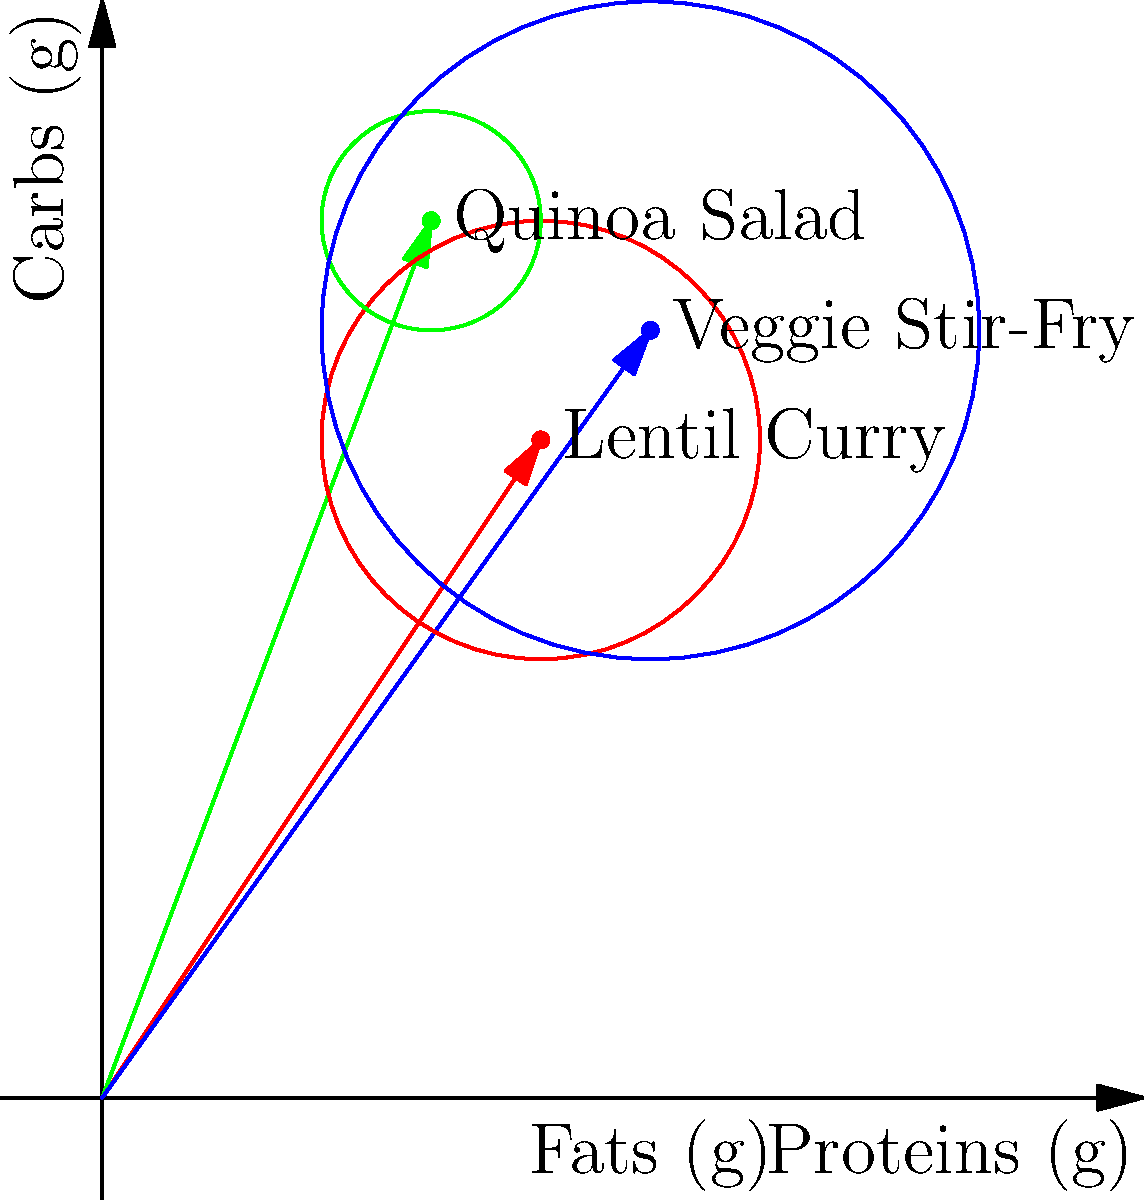Given the nutritional vectors for three vegetarian dishes (Lentil Curry, Quinoa Salad, and Veggie Stir-Fry) represented in the graph, where the x-axis shows proteins, y-axis shows carbs, and the circle size represents fats, calculate the total nutritional vector for a balanced meal consisting of equal portions of all three dishes. Express your answer as a vector in the form $(p, c, f)$, where $p$ is total proteins, $c$ is total carbs, and $f$ is total fats. To calculate the total nutritional vector for a balanced meal with equal portions of all three dishes, we need to follow these steps:

1. Identify the nutritional values for each dish:
   Lentil Curry: (20g protein, 30g carbs, 10g fat)
   Quinoa Salad: (15g protein, 40g carbs, 5g fat)
   Veggie Stir-Fry: (25g protein, 35g carbs, 15g fat)

2. Since we're using equal portions of each dish, we need to sum up the values for each nutrient:

   Proteins: $20 + 15 + 25 = 60$ g
   Carbs: $30 + 40 + 35 = 105$ g
   Fats: $10 + 5 + 15 = 30$ g

3. The resulting vector represents the total nutritional value of the balanced meal:
   $(60, 105, 30)$

This vector gives us the total grams of proteins, carbs, and fats in the combined meal.
Answer: $(60, 105, 30)$ 